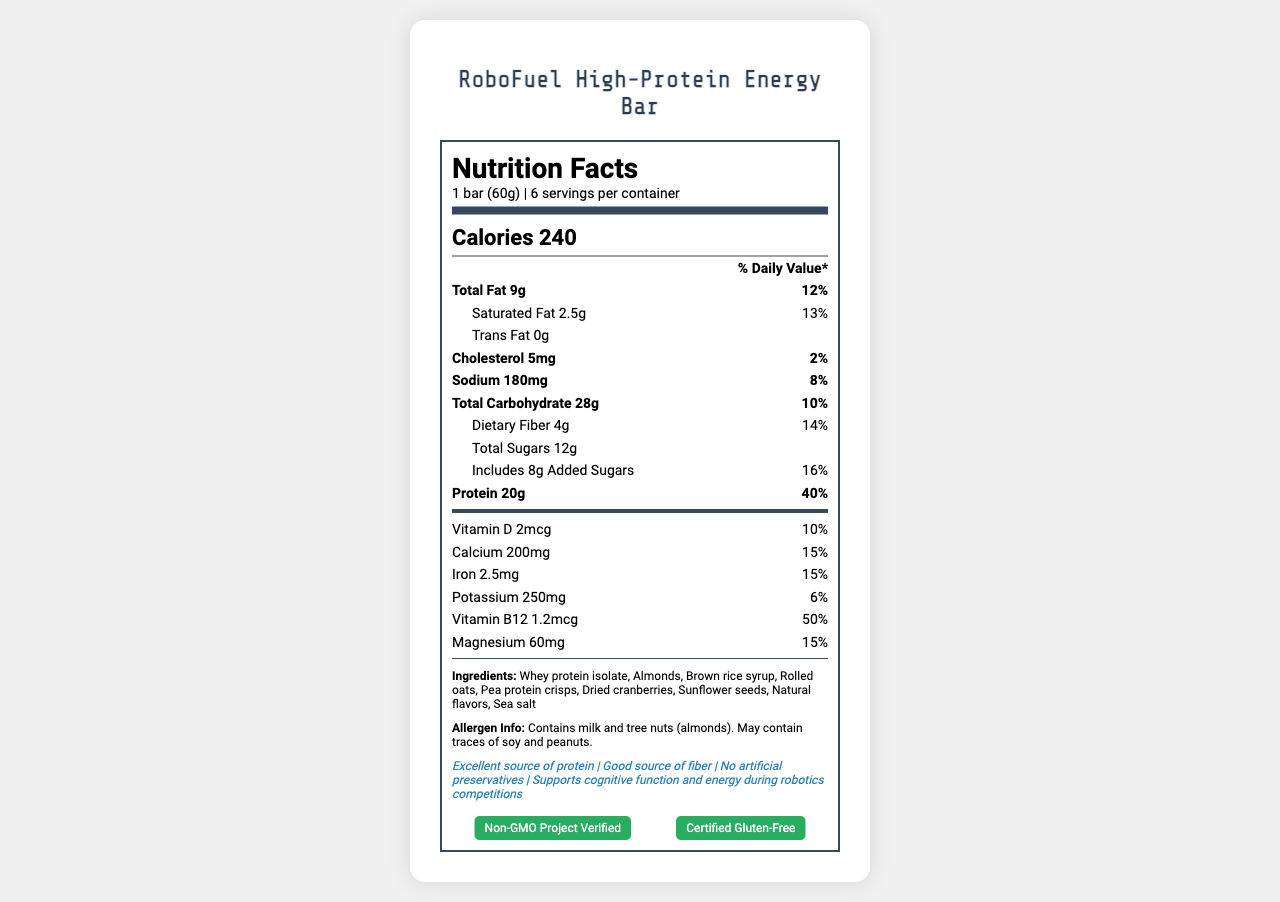what is the serving size of RoboFuel High-Protein Energy Bar? The serving size is listed at the top of the nutrition label as "1 bar (60g)".
Answer: 1 bar (60g) How many servings are there per container? The number of servings per container is listed right below the serving size, showing "6 servings per container".
Answer: 6 What is the total fat content per serving? The total fat content per serving is listed under "Total Fat" as "9g".
Answer: 9g What percentage of the daily value of protein does one bar provide? The protein content is listed as providing 40% of the daily value per serving.
Answer: 40% Which ingredient is listed first in the ingredients list? The ingredients list starts with "Whey protein isolate".
Answer: Whey protein isolate How much dietary fiber does each bar contain? The dietary fiber content per serving is shown as "4g".
Answer: 4g Include all oxygen-producing ingredients in RoboFuel High-Protein Energy Bar. A. Whey protein isolate B. Almonds C. Rolled oats Rolled oats are likely to be the oxygen-producing ingredients as they are plant-based.
Answer: C What is the sodium content per serving of the energy bar? 1. 180mg 2. 200mg 3. 250mg 4. 300mg The sodium content is listed as 180mg per serving.
Answer: 1. 180mg Does the energy bar contain any artificial preservatives? One of the claim statements explicitly mentions "No artificial preservatives".
Answer: No Can this product be consumed by someone with a peanut allergy? The allergen information states that the product may contain traces of peanuts.
Answer: No Summarize what the RoboFuel High-Protein Energy Bar claims to support. The claim statements on the label mention, "Supports cognitive function and energy during robotics competitions".
Answer: Supports cognitive function and energy during robotics competitions What is the manufacturing address of the RoboFuel High-Protein Energy Bar? The manufacturer's address is provided at the bottom of the document.
Answer: TechNutrition Labs, 123 Innovation Way, Silicon Valley, CA 94085 How much added sugars are present per serving? The added sugars content is listed as "8g".
Answer: 8g Does the RoboFuel High-Protein Energy Bar help in muscle recovery? The nutrition facts label does not provide specific information about muscle recovery benefits.
Answer: Not enough information What certifications does the RoboFuel High-Protein Energy Bar have? The certifications are listed as "Non-GMO Project Verified" and "Certified Gluten-Free".
Answer: Non-GMO Project Verified, Certified Gluten-Free Which vitamin in the energy bar has the highest percentage of daily value? The energy bar contains 50% of the daily value of Vitamin B12, the highest percentage among the vitamins listed.
Answer: Vitamin B12 